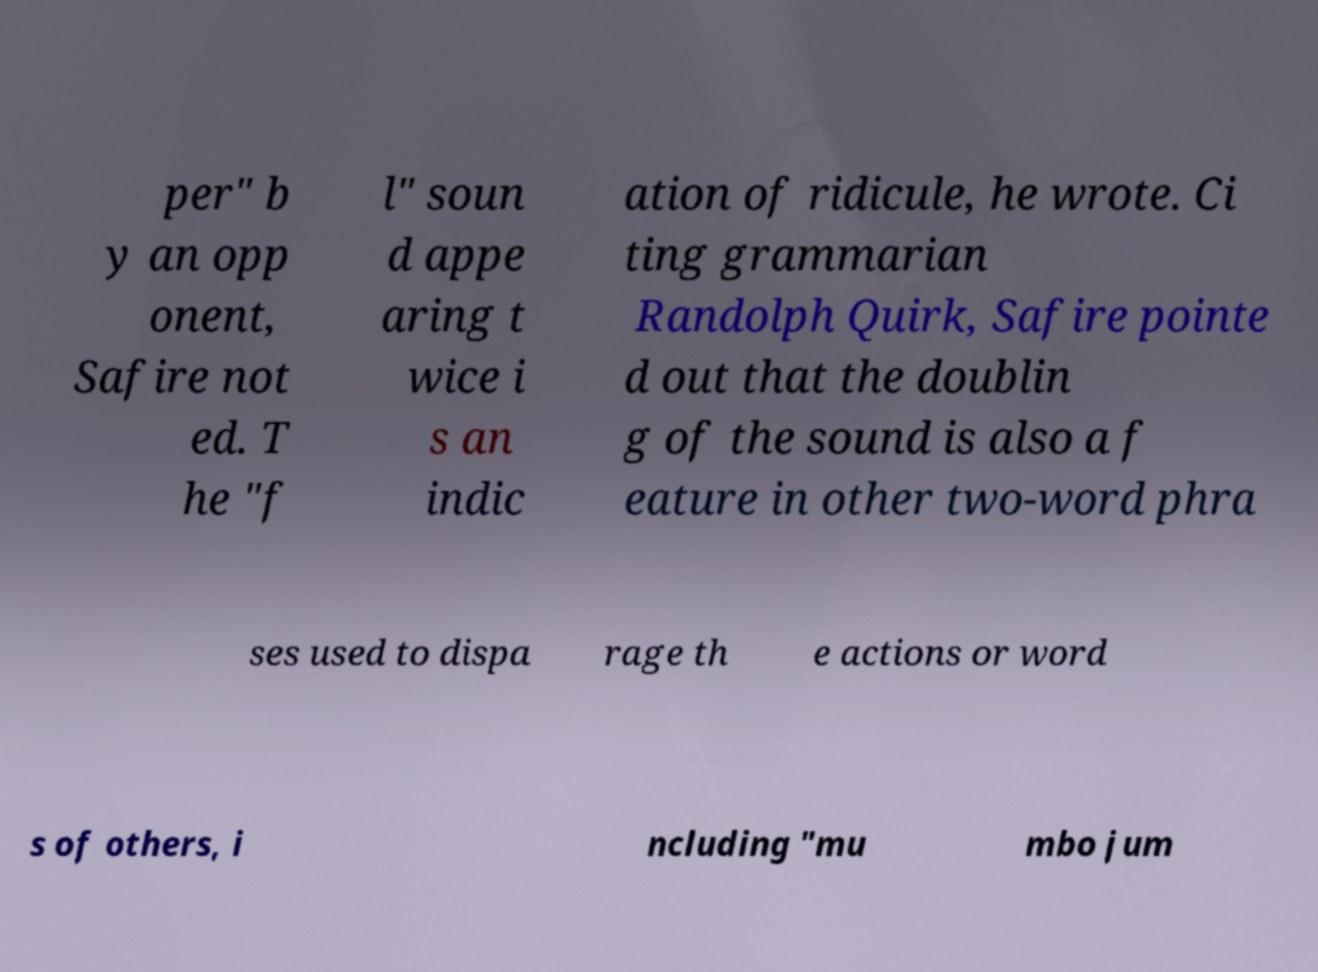Could you assist in decoding the text presented in this image and type it out clearly? per" b y an opp onent, Safire not ed. T he "f l" soun d appe aring t wice i s an indic ation of ridicule, he wrote. Ci ting grammarian Randolph Quirk, Safire pointe d out that the doublin g of the sound is also a f eature in other two-word phra ses used to dispa rage th e actions or word s of others, i ncluding "mu mbo jum 